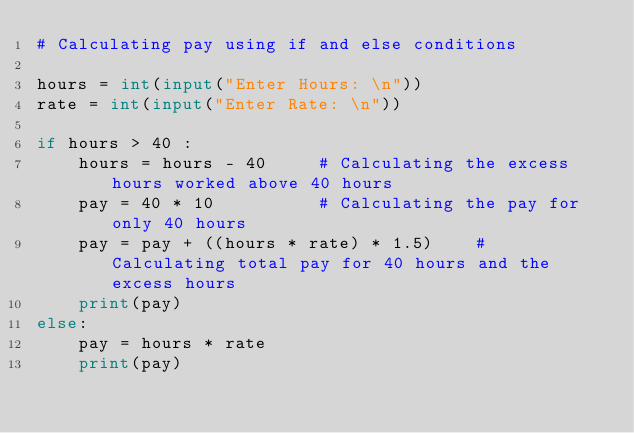<code> <loc_0><loc_0><loc_500><loc_500><_Python_># Calculating pay using if and else conditions

hours = int(input("Enter Hours: \n"))
rate = int(input("Enter Rate: \n"))

if hours > 40 :
    hours = hours - 40     # Calculating the excess hours worked above 40 hours
    pay = 40 * 10          # Calculating the pay for only 40 hours
    pay = pay + ((hours * rate) * 1.5)    # Calculating total pay for 40 hours and the excess hours
    print(pay)
else:
    pay = hours * rate
    print(pay)</code> 